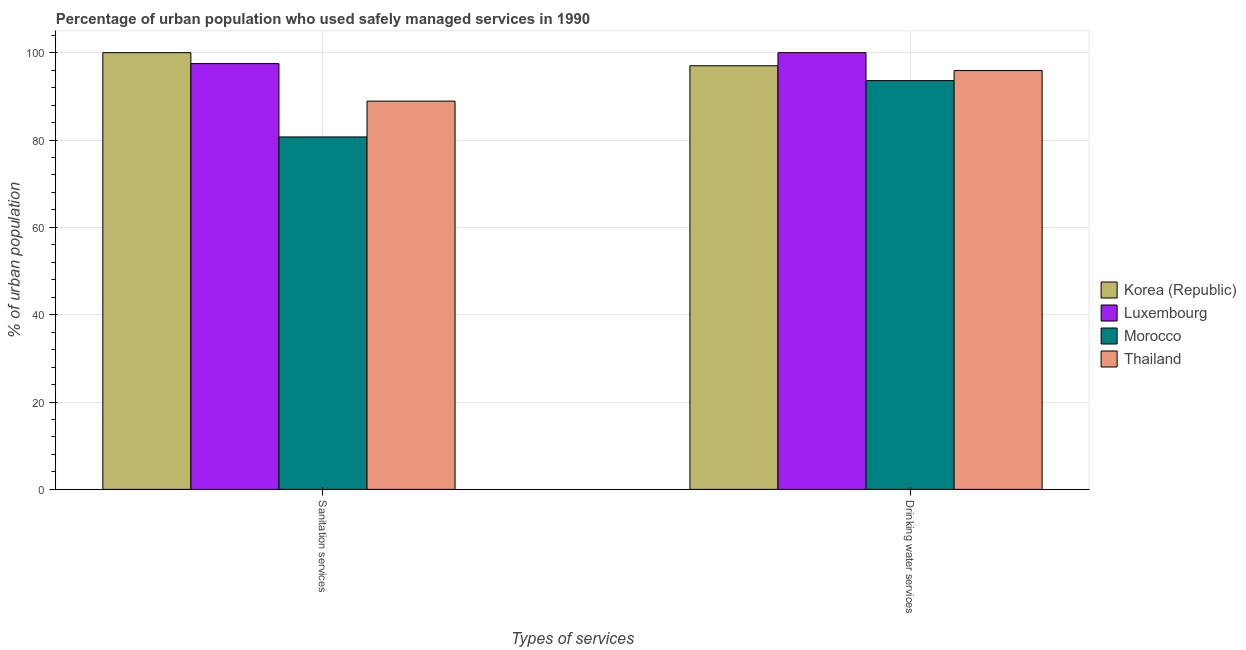Are the number of bars per tick equal to the number of legend labels?
Make the answer very short. Yes. Are the number of bars on each tick of the X-axis equal?
Give a very brief answer. Yes. How many bars are there on the 1st tick from the left?
Your response must be concise. 4. What is the label of the 2nd group of bars from the left?
Ensure brevity in your answer.  Drinking water services. What is the percentage of urban population who used sanitation services in Morocco?
Provide a succinct answer. 80.7. Across all countries, what is the minimum percentage of urban population who used drinking water services?
Offer a very short reply. 93.6. In which country was the percentage of urban population who used drinking water services maximum?
Keep it short and to the point. Luxembourg. In which country was the percentage of urban population who used drinking water services minimum?
Your answer should be very brief. Morocco. What is the total percentage of urban population who used sanitation services in the graph?
Your response must be concise. 367.1. What is the difference between the percentage of urban population who used sanitation services in Morocco and that in Korea (Republic)?
Your response must be concise. -19.3. What is the difference between the percentage of urban population who used sanitation services in Morocco and the percentage of urban population who used drinking water services in Thailand?
Keep it short and to the point. -15.2. What is the average percentage of urban population who used drinking water services per country?
Offer a terse response. 96.62. What is the difference between the percentage of urban population who used drinking water services and percentage of urban population who used sanitation services in Morocco?
Offer a terse response. 12.9. What is the ratio of the percentage of urban population who used sanitation services in Thailand to that in Morocco?
Offer a very short reply. 1.1. Is the percentage of urban population who used sanitation services in Korea (Republic) less than that in Luxembourg?
Make the answer very short. No. In how many countries, is the percentage of urban population who used drinking water services greater than the average percentage of urban population who used drinking water services taken over all countries?
Your answer should be very brief. 2. What does the 2nd bar from the left in Drinking water services represents?
Keep it short and to the point. Luxembourg. What does the 1st bar from the right in Drinking water services represents?
Your answer should be compact. Thailand. How many bars are there?
Your answer should be very brief. 8. Are all the bars in the graph horizontal?
Provide a short and direct response. No. Are the values on the major ticks of Y-axis written in scientific E-notation?
Provide a succinct answer. No. Does the graph contain any zero values?
Keep it short and to the point. No. Where does the legend appear in the graph?
Provide a succinct answer. Center right. How are the legend labels stacked?
Your response must be concise. Vertical. What is the title of the graph?
Offer a very short reply. Percentage of urban population who used safely managed services in 1990. What is the label or title of the X-axis?
Make the answer very short. Types of services. What is the label or title of the Y-axis?
Keep it short and to the point. % of urban population. What is the % of urban population of Luxembourg in Sanitation services?
Ensure brevity in your answer.  97.5. What is the % of urban population of Morocco in Sanitation services?
Offer a very short reply. 80.7. What is the % of urban population in Thailand in Sanitation services?
Provide a short and direct response. 88.9. What is the % of urban population of Korea (Republic) in Drinking water services?
Give a very brief answer. 97. What is the % of urban population in Morocco in Drinking water services?
Keep it short and to the point. 93.6. What is the % of urban population of Thailand in Drinking water services?
Offer a very short reply. 95.9. Across all Types of services, what is the maximum % of urban population of Luxembourg?
Offer a terse response. 100. Across all Types of services, what is the maximum % of urban population of Morocco?
Keep it short and to the point. 93.6. Across all Types of services, what is the maximum % of urban population of Thailand?
Offer a terse response. 95.9. Across all Types of services, what is the minimum % of urban population in Korea (Republic)?
Your response must be concise. 97. Across all Types of services, what is the minimum % of urban population in Luxembourg?
Keep it short and to the point. 97.5. Across all Types of services, what is the minimum % of urban population in Morocco?
Make the answer very short. 80.7. Across all Types of services, what is the minimum % of urban population in Thailand?
Give a very brief answer. 88.9. What is the total % of urban population in Korea (Republic) in the graph?
Make the answer very short. 197. What is the total % of urban population of Luxembourg in the graph?
Offer a terse response. 197.5. What is the total % of urban population in Morocco in the graph?
Offer a very short reply. 174.3. What is the total % of urban population of Thailand in the graph?
Provide a short and direct response. 184.8. What is the difference between the % of urban population in Luxembourg in Sanitation services and that in Drinking water services?
Give a very brief answer. -2.5. What is the difference between the % of urban population of Morocco in Sanitation services and that in Drinking water services?
Provide a short and direct response. -12.9. What is the difference between the % of urban population in Korea (Republic) in Sanitation services and the % of urban population in Luxembourg in Drinking water services?
Provide a short and direct response. 0. What is the difference between the % of urban population of Korea (Republic) in Sanitation services and the % of urban population of Morocco in Drinking water services?
Make the answer very short. 6.4. What is the difference between the % of urban population in Luxembourg in Sanitation services and the % of urban population in Morocco in Drinking water services?
Your answer should be compact. 3.9. What is the difference between the % of urban population of Luxembourg in Sanitation services and the % of urban population of Thailand in Drinking water services?
Give a very brief answer. 1.6. What is the difference between the % of urban population of Morocco in Sanitation services and the % of urban population of Thailand in Drinking water services?
Make the answer very short. -15.2. What is the average % of urban population in Korea (Republic) per Types of services?
Your answer should be very brief. 98.5. What is the average % of urban population in Luxembourg per Types of services?
Give a very brief answer. 98.75. What is the average % of urban population of Morocco per Types of services?
Keep it short and to the point. 87.15. What is the average % of urban population in Thailand per Types of services?
Provide a short and direct response. 92.4. What is the difference between the % of urban population in Korea (Republic) and % of urban population in Morocco in Sanitation services?
Make the answer very short. 19.3. What is the difference between the % of urban population in Korea (Republic) and % of urban population in Thailand in Sanitation services?
Keep it short and to the point. 11.1. What is the difference between the % of urban population in Luxembourg and % of urban population in Morocco in Sanitation services?
Give a very brief answer. 16.8. What is the difference between the % of urban population in Luxembourg and % of urban population in Thailand in Sanitation services?
Ensure brevity in your answer.  8.6. What is the difference between the % of urban population of Korea (Republic) and % of urban population of Morocco in Drinking water services?
Provide a succinct answer. 3.4. What is the difference between the % of urban population of Morocco and % of urban population of Thailand in Drinking water services?
Offer a very short reply. -2.3. What is the ratio of the % of urban population of Korea (Republic) in Sanitation services to that in Drinking water services?
Offer a terse response. 1.03. What is the ratio of the % of urban population in Morocco in Sanitation services to that in Drinking water services?
Make the answer very short. 0.86. What is the ratio of the % of urban population in Thailand in Sanitation services to that in Drinking water services?
Make the answer very short. 0.93. What is the difference between the highest and the lowest % of urban population in Korea (Republic)?
Give a very brief answer. 3. What is the difference between the highest and the lowest % of urban population in Morocco?
Make the answer very short. 12.9. What is the difference between the highest and the lowest % of urban population of Thailand?
Provide a succinct answer. 7. 